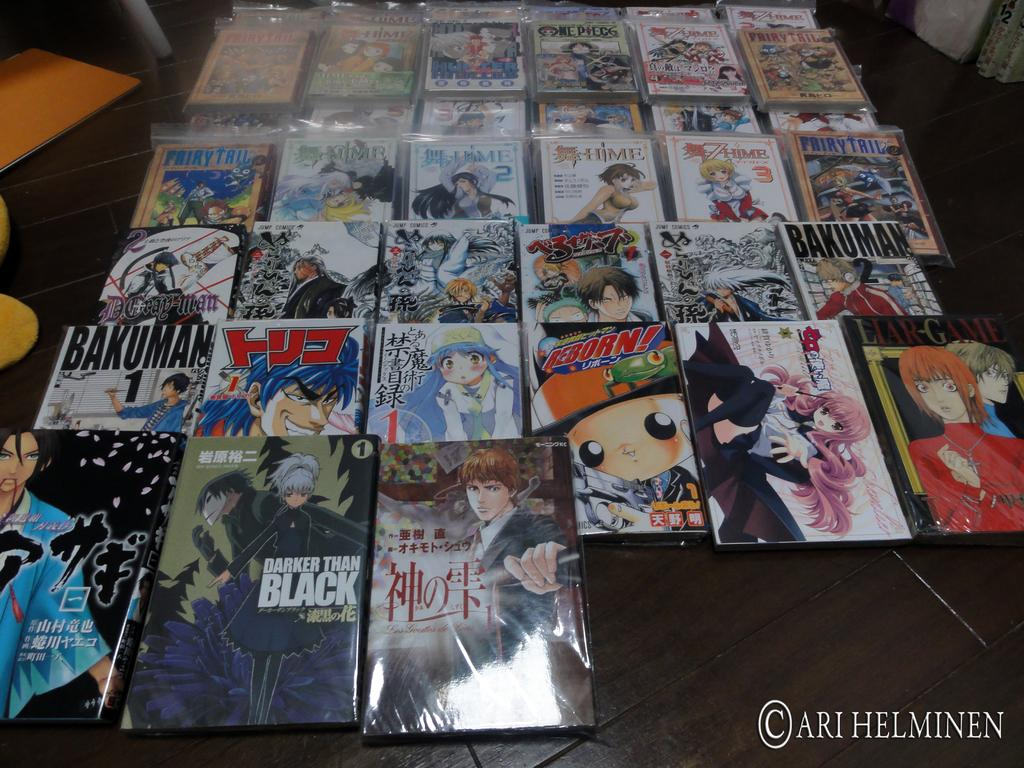<image>
Relay a brief, clear account of the picture shown. The picture here is from the artist Ari Helminen 